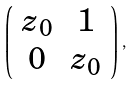<formula> <loc_0><loc_0><loc_500><loc_500>\left ( \begin{array} { c c } z _ { 0 } & 1 \\ 0 & z _ { 0 } \\ \end{array} \right ) \, ,</formula> 